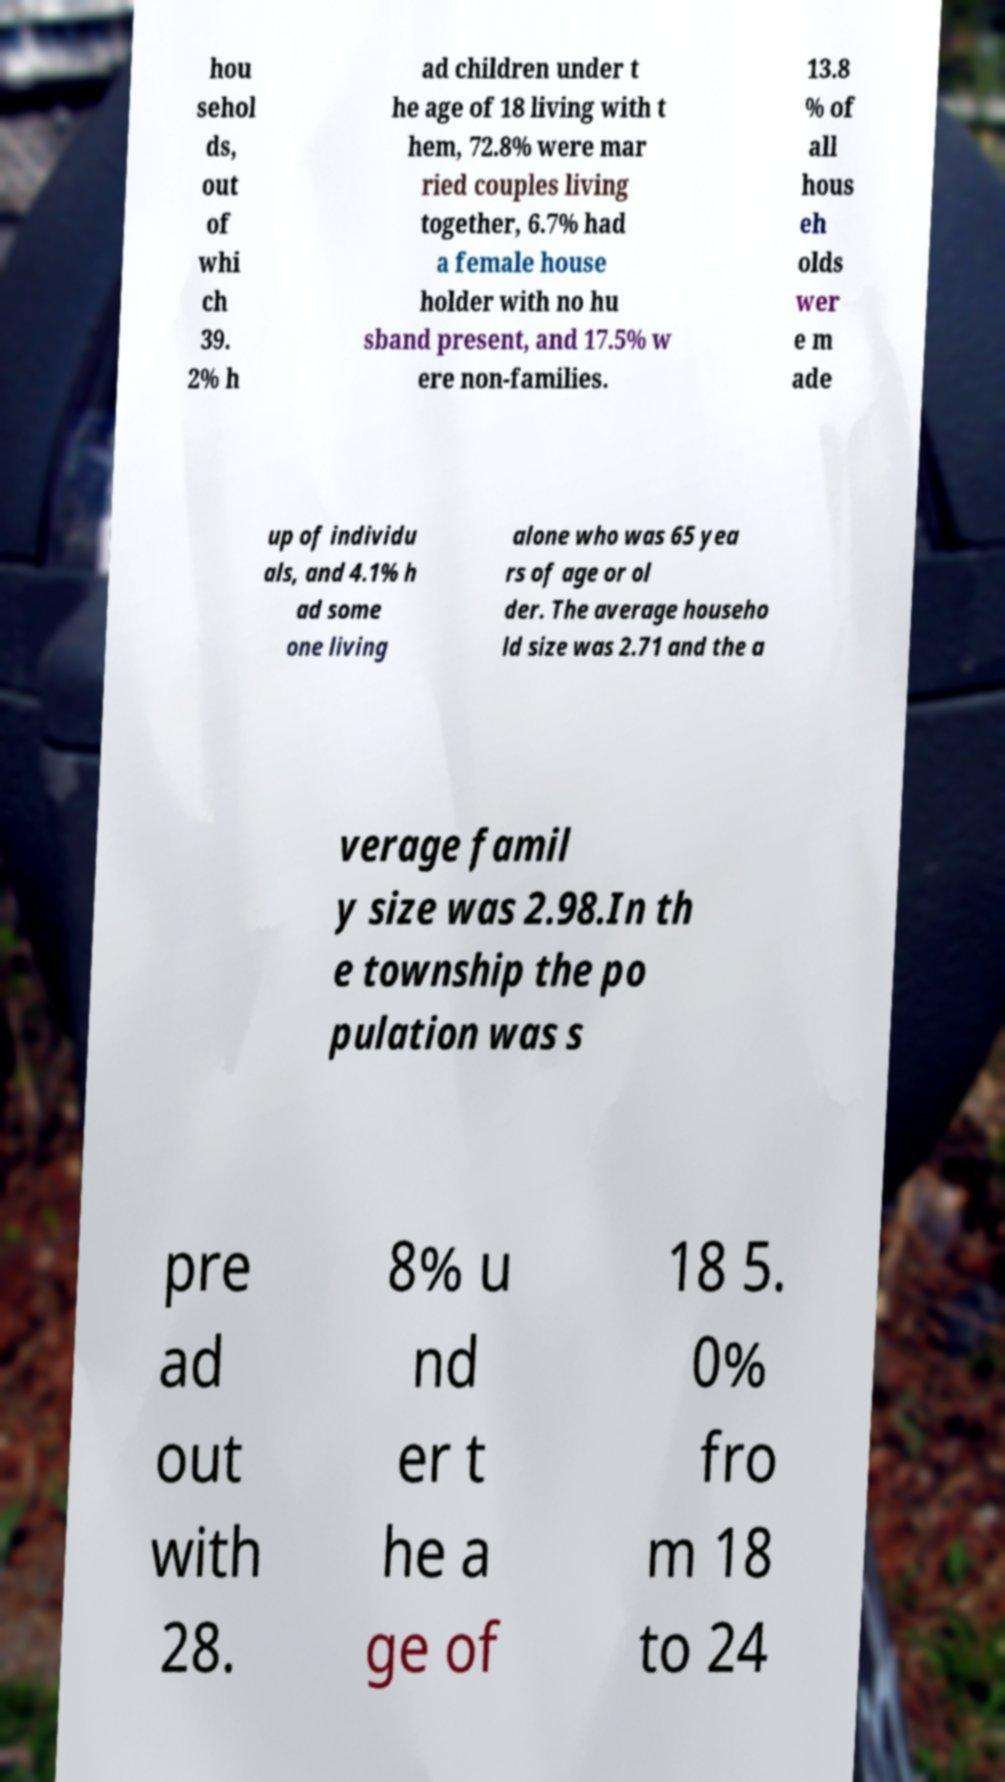What messages or text are displayed in this image? I need them in a readable, typed format. hou sehol ds, out of whi ch 39. 2% h ad children under t he age of 18 living with t hem, 72.8% were mar ried couples living together, 6.7% had a female house holder with no hu sband present, and 17.5% w ere non-families. 13.8 % of all hous eh olds wer e m ade up of individu als, and 4.1% h ad some one living alone who was 65 yea rs of age or ol der. The average househo ld size was 2.71 and the a verage famil y size was 2.98.In th e township the po pulation was s pre ad out with 28. 8% u nd er t he a ge of 18 5. 0% fro m 18 to 24 